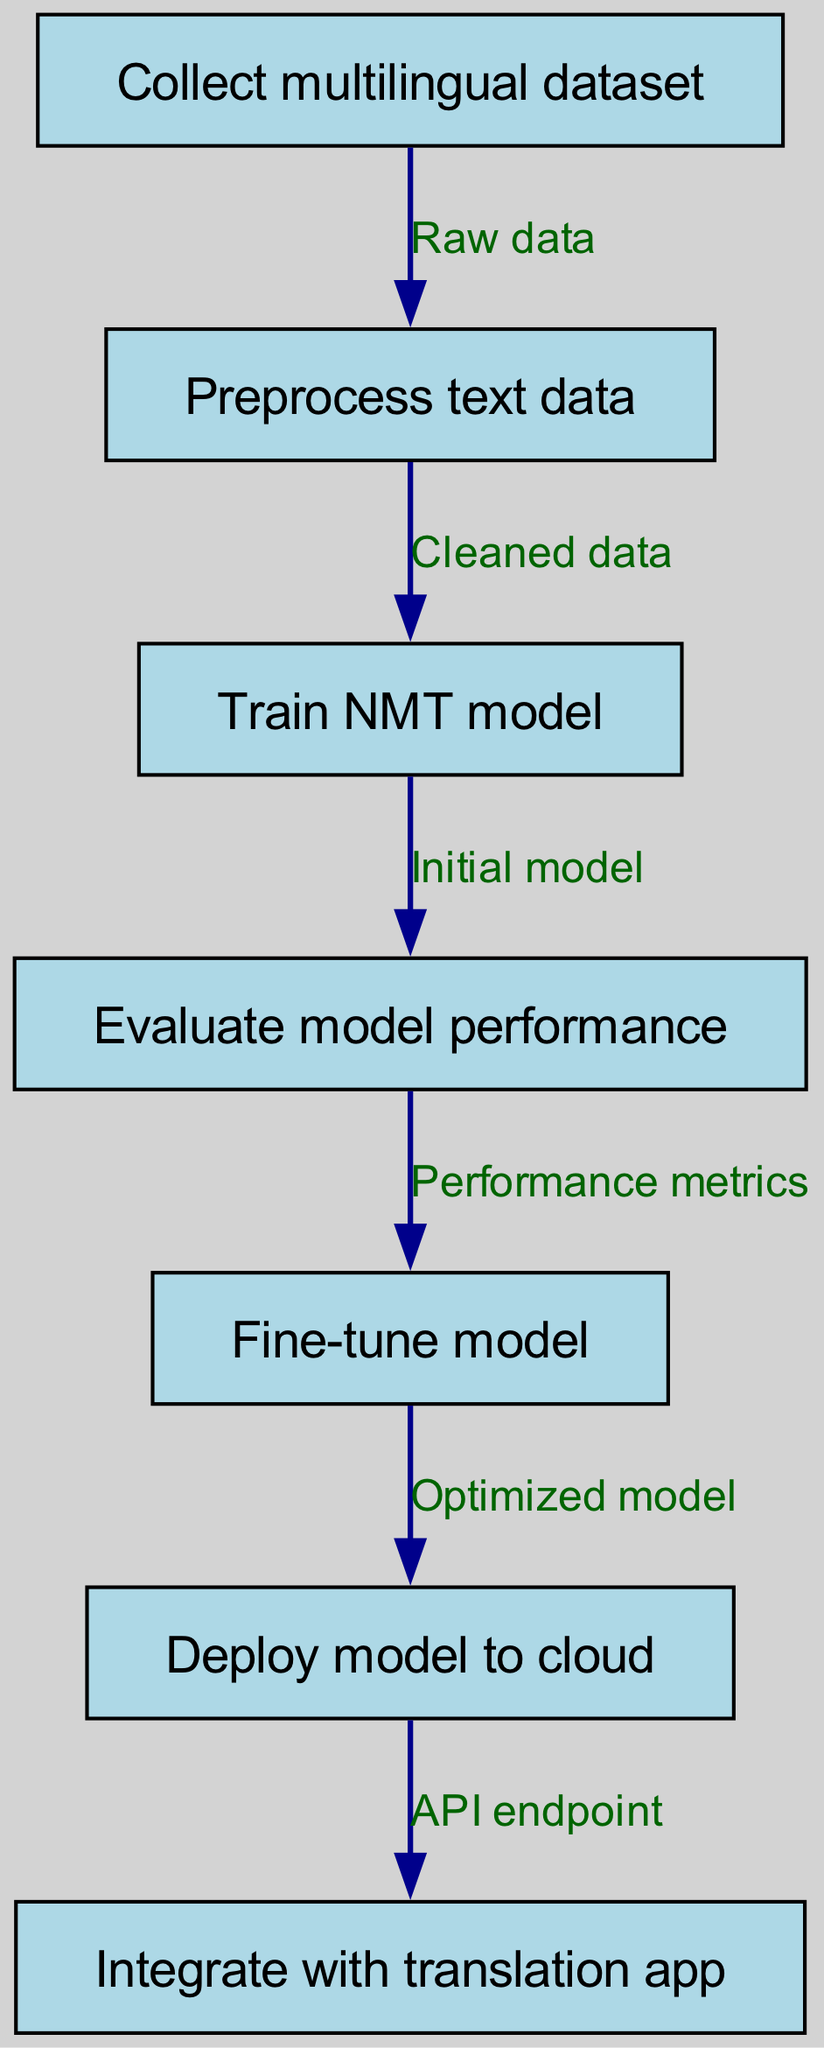What is the first step in the process? The first step in the flowchart is "Collect multilingual dataset," which is the initial action before any processing occurs.
Answer: Collect multilingual dataset How many nodes are in the diagram? By counting all the nodes listed in the diagram, we find there are a total of seven distinct steps involved in the process.
Answer: Seven What is the output of the "Train NMT model" step? The output from the "Train NMT model" node is "Initial model," signifying the completion of the training process.
Answer: Initial model What is the relationship between "Evaluate model performance" and "Fine-tune model"? The relationship is that "Evaluate model performance" provides "Performance metrics," which are used as input to the following step, "Fine-tune model."
Answer: Performance metrics What do you do after "Fine-tune model"? After "Fine-tune model," the next action is to "Deploy model to cloud," indicating the progression to deploying the trained model.
Answer: Deploy model to cloud How does the flowchart represent the transition from the model training to deployment? The flowchart shows that after "Fine-tune model," which yields an "Optimized model," the next node is "Deploy model to cloud," indicating a direct transition from training to deployment.
Answer: Deploy model to cloud Which node is responsible for integrating the model into the translation app? The node responsible for the integration is "Integrate with translation app," as this is the final step in the process.
Answer: Integrate with translation app What type of data is passed from "Preprocess text data" to "Train NMT model"? The data passed from "Preprocess text data" to "Train NMT model" is referred to as "Cleaned data," which follows a preprocessing step.
Answer: Cleaned data What action is taken when the model performance falls short? When model performance is not satisfactory, the action taken is to "Fine-tune model," which is aimed at improving performance metrics.
Answer: Fine-tune model 